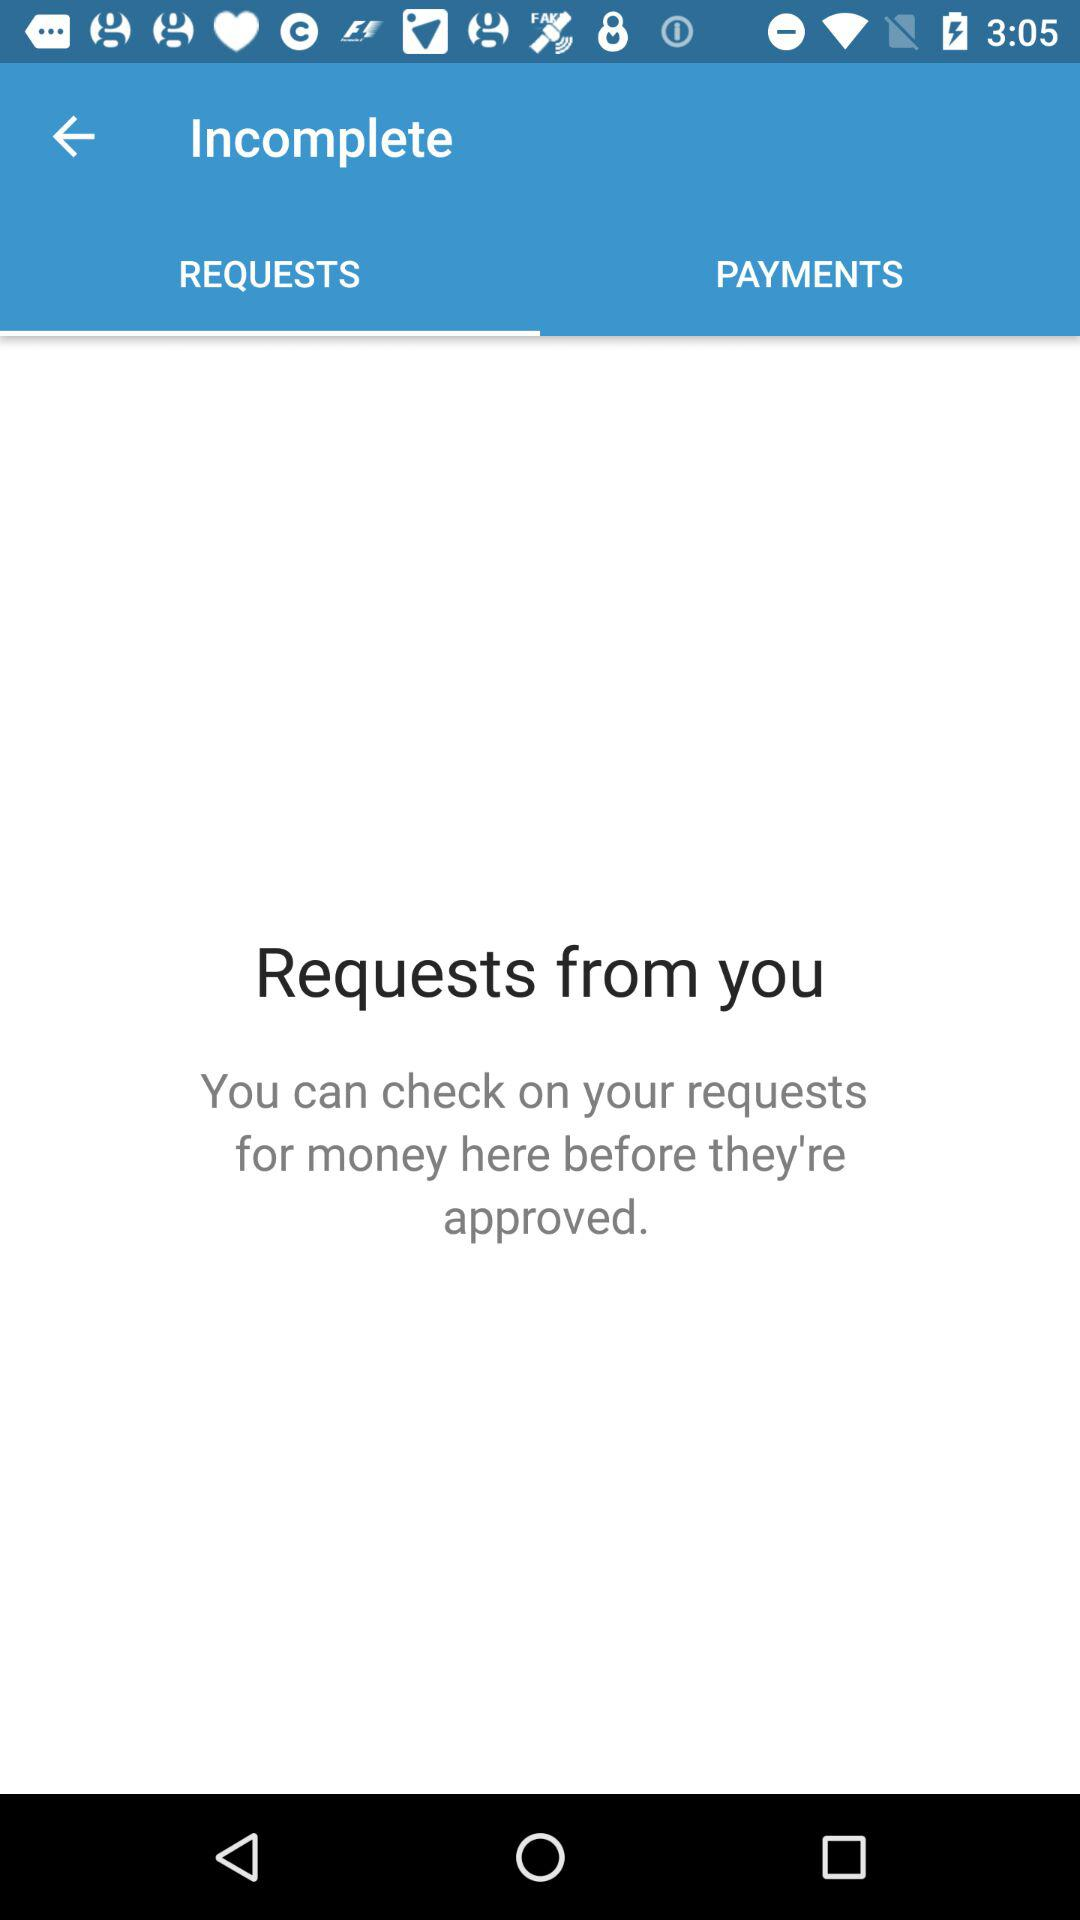Which tab is selected? The selected tab is "REQUESTS". 